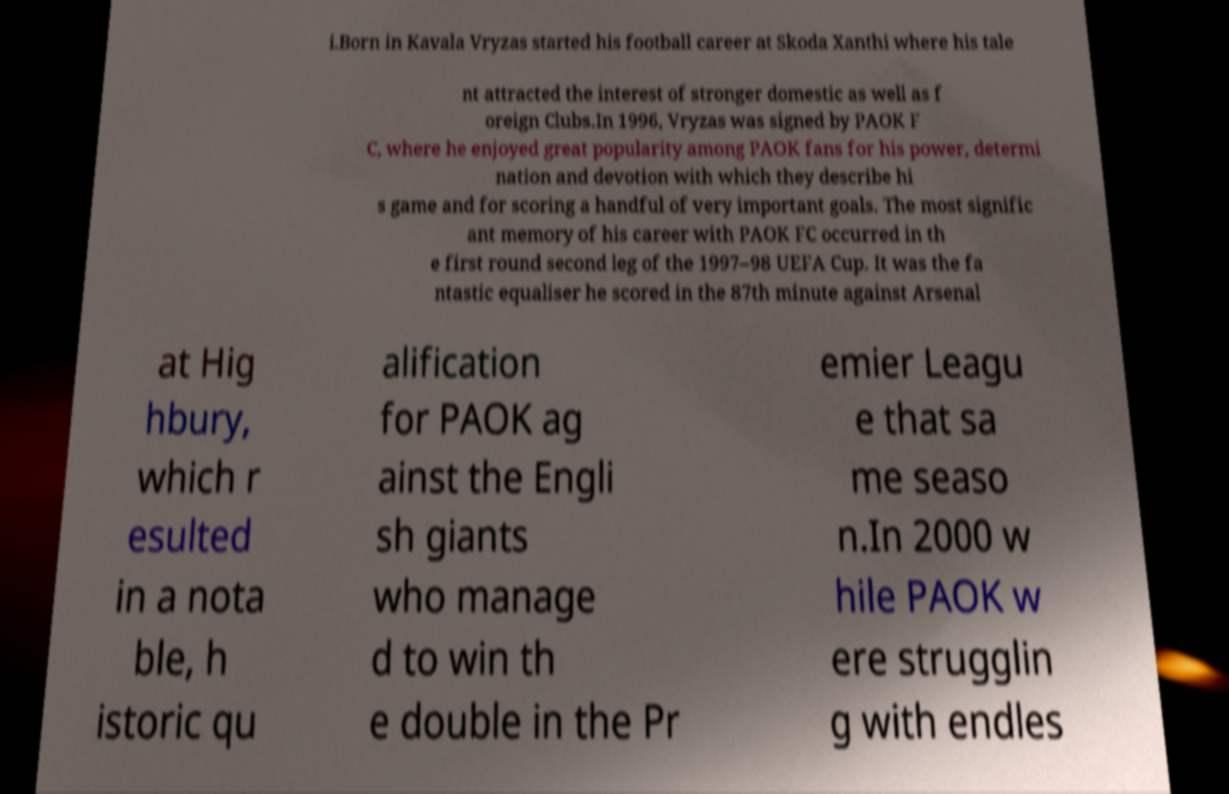Can you accurately transcribe the text from the provided image for me? i.Born in Kavala Vryzas started his football career at Skoda Xanthi where his tale nt attracted the interest of stronger domestic as well as f oreign Clubs.In 1996, Vryzas was signed by PAOK F C, where he enjoyed great popularity among PAOK fans for his power, determi nation and devotion with which they describe hi s game and for scoring a handful of very important goals. The most signific ant memory of his career with PAOK FC occurred in th e first round second leg of the 1997–98 UEFA Cup. It was the fa ntastic equaliser he scored in the 87th minute against Arsenal at Hig hbury, which r esulted in a nota ble, h istoric qu alification for PAOK ag ainst the Engli sh giants who manage d to win th e double in the Pr emier Leagu e that sa me seaso n.In 2000 w hile PAOK w ere strugglin g with endles 